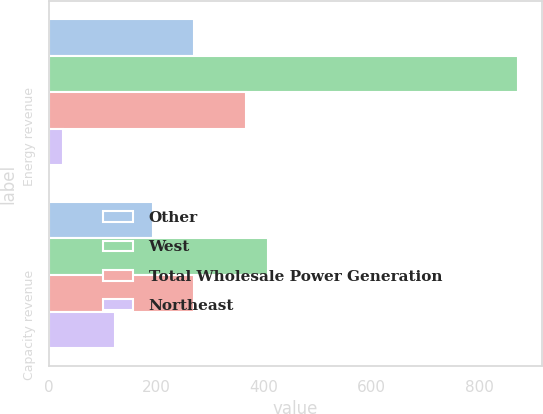Convert chart. <chart><loc_0><loc_0><loc_500><loc_500><stacked_bar_chart><ecel><fcel>Energy revenue<fcel>Capacity revenue<nl><fcel>Other<fcel>269<fcel>193<nl><fcel>West<fcel>873<fcel>407<nl><fcel>Total Wholesale Power Generation<fcel>367<fcel>269<nl><fcel>Northeast<fcel>26<fcel>122<nl></chart> 